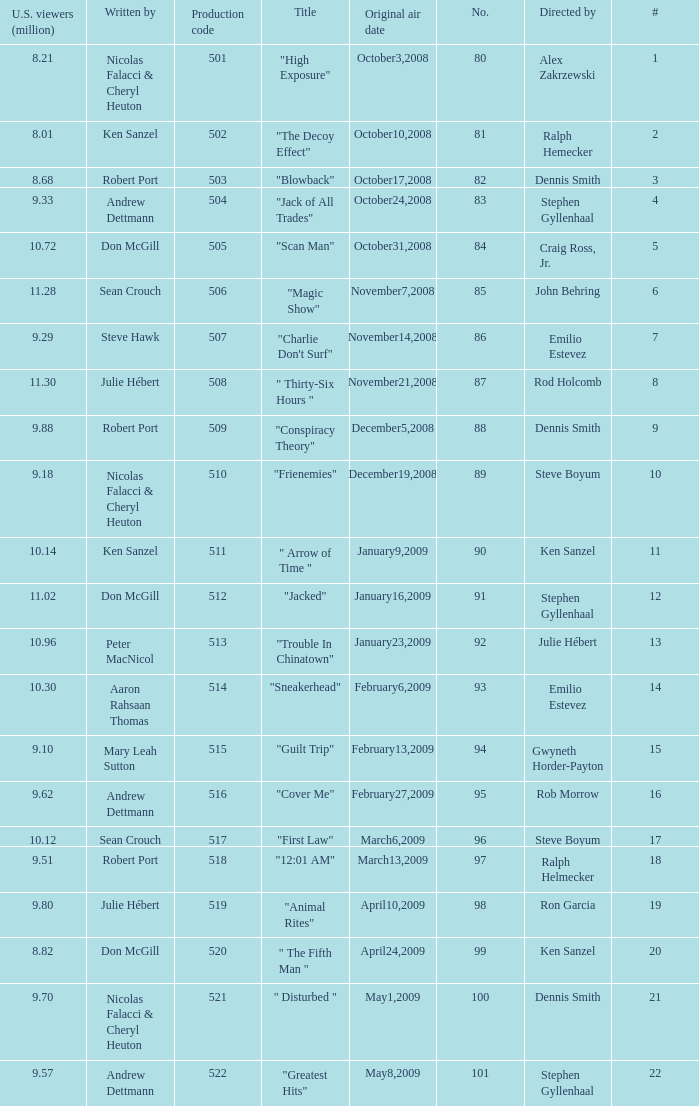How many times did episode 6 originally air? 1.0. 